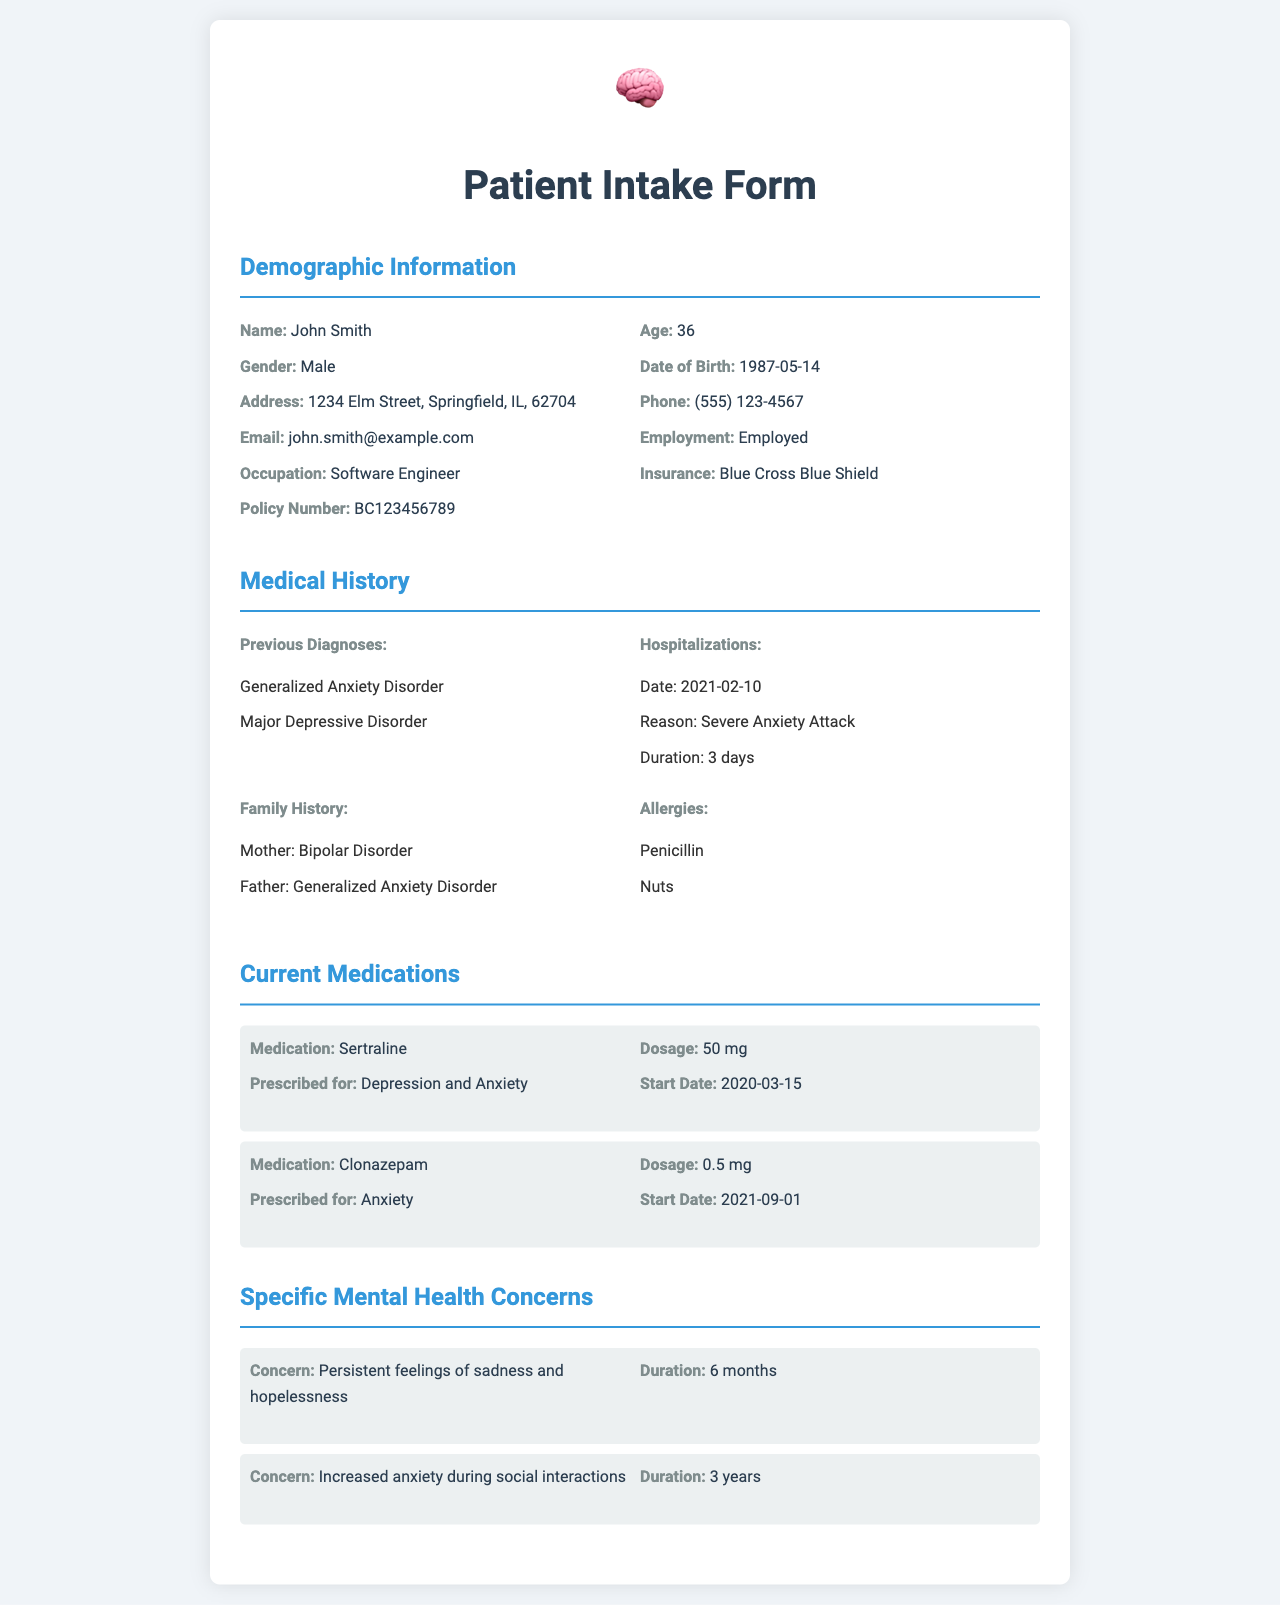What is the name of the patient? The patient's name is listed under Demographic Information.
Answer: John Smith What is the patient's age? The age can be found in the Demographic Information section.
Answer: 36 When was the medication Sertraline started? This information is provided under Current Medications.
Answer: 2020-03-15 What is the main concern related to anxiety? The specific anxiety concern is detailed in the Specific Mental Health Concerns section.
Answer: Increased anxiety during social interactions How long has the patient experienced persistent feelings of sadness? The duration of this specific concern is mentioned in the Specific Mental Health Concerns section.
Answer: 6 months What type of insurance does the patient have? Information about insurance is found under Demographic Information.
Answer: Blue Cross Blue Shield Which family member has bipolar disorder? The family history section details conditions related to family members.
Answer: Mother How many hospitalizations has the patient had according to the medical history? The medical history section outlines details about hospitalizations.
Answer: 1 What is the prescribed dosage of Clonazepam? The Current Medications section provides the prescribed dosage.
Answer: 0.5 mg What is the occupation of the patient? The patient’s occupation is listed under Demographic Information.
Answer: Software Engineer 